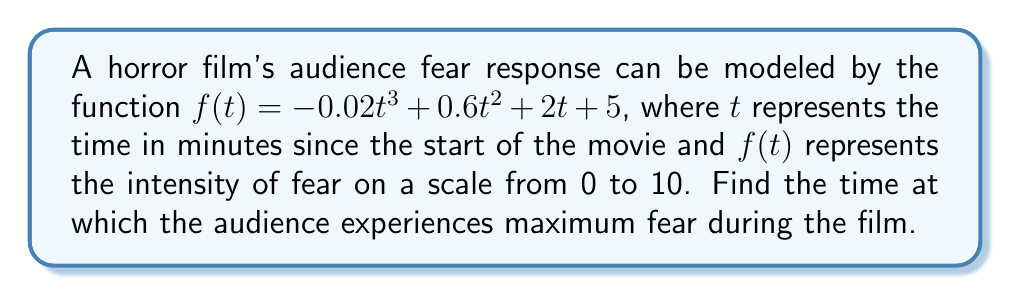Solve this math problem. To find the maximum point of the function, we need to follow these steps:

1. Find the derivative of the function:
   $$f'(t) = -0.06t^2 + 1.2t + 2$$

2. Set the derivative equal to zero and solve for t:
   $$-0.06t^2 + 1.2t + 2 = 0$$

3. This is a quadratic equation. We can solve it using the quadratic formula:
   $$t = \frac{-b \pm \sqrt{b^2 - 4ac}}{2a}$$
   where $a = -0.06$, $b = 1.2$, and $c = 2$

4. Substituting these values:
   $$t = \frac{-1.2 \pm \sqrt{1.44 - 4(-0.06)(2)}}{2(-0.06)}$$
   $$t = \frac{-1.2 \pm \sqrt{1.44 + 0.48}}{-0.12}$$
   $$t = \frac{-1.2 \pm \sqrt{1.92}}{-0.12}$$
   $$t = \frac{-1.2 \pm 1.3856}{-0.12}$$

5. This gives us two solutions:
   $$t_1 = \frac{-1.2 + 1.3856}{-0.12} \approx -1.55$$
   $$t_2 = \frac{-1.2 - 1.3856}{-0.12} \approx 21.55$$

6. Since time cannot be negative in this context, we discard the negative solution.

7. To confirm this is a maximum (not a minimum), we can check the second derivative:
   $$f''(t) = -0.12t + 1.2$$
   $$f''(21.55) = -0.12(21.55) + 1.2 = -1.386 < 0$$

   Since the second derivative is negative at this point, it confirms this is a maximum.
Answer: 21.55 minutes 